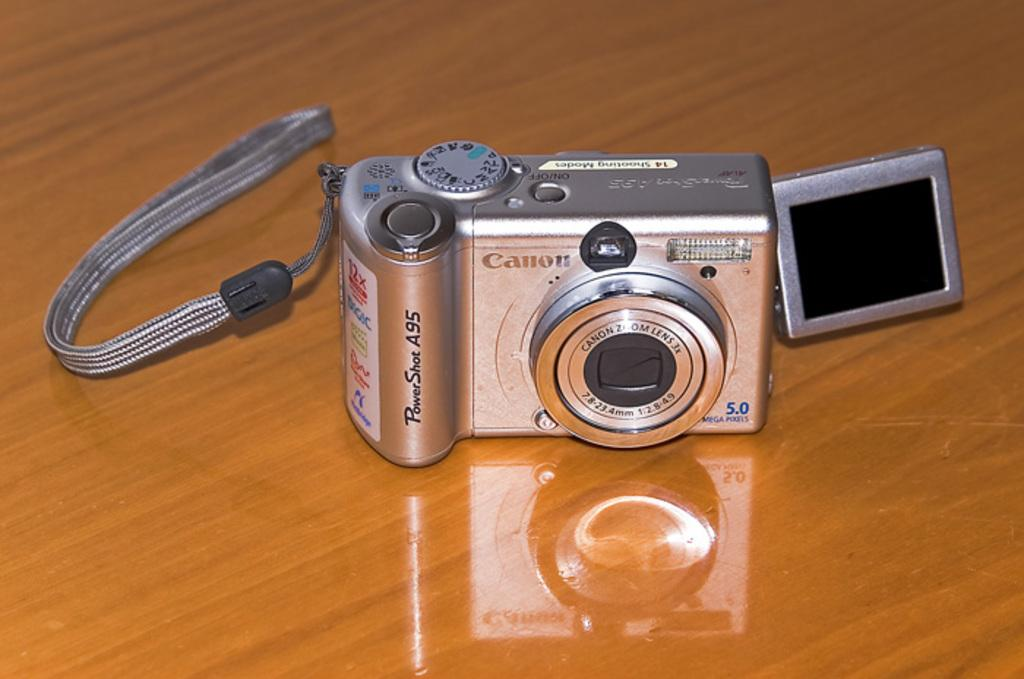What is the main object in the image? There is a digital camera in the image. Where is the digital camera located? The digital camera is on a wooden table. What type of shoes is the minister wearing in the image? There is no minister or shoes present in the image; it only features a digital camera on a wooden table. 